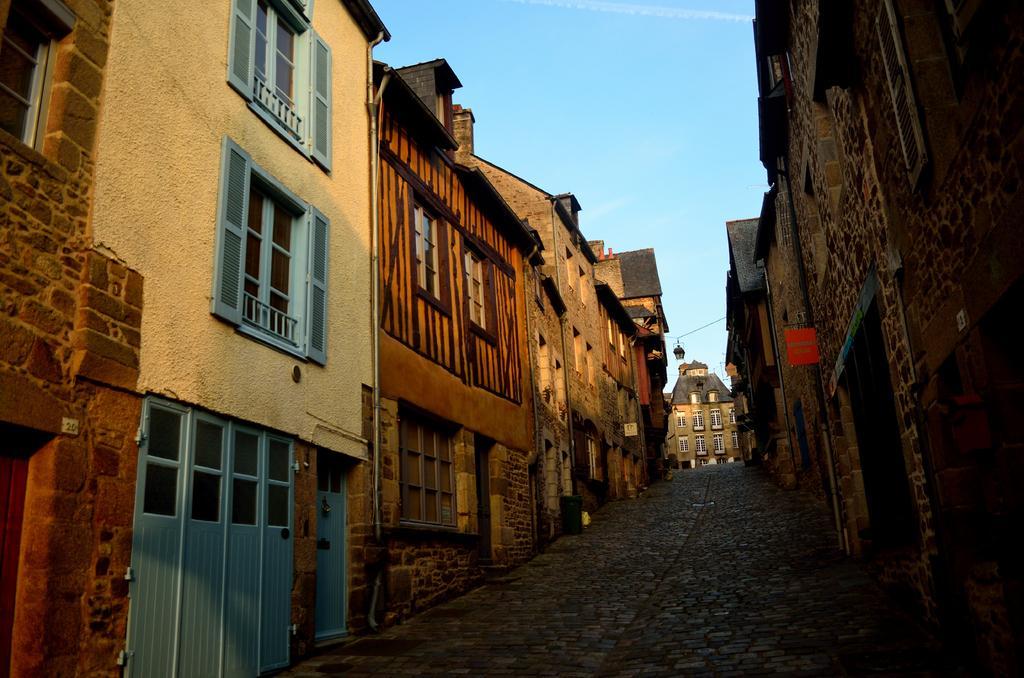Please provide a concise description of this image. In this image we can see some buildings, windows, doors, also we can see the sky. 